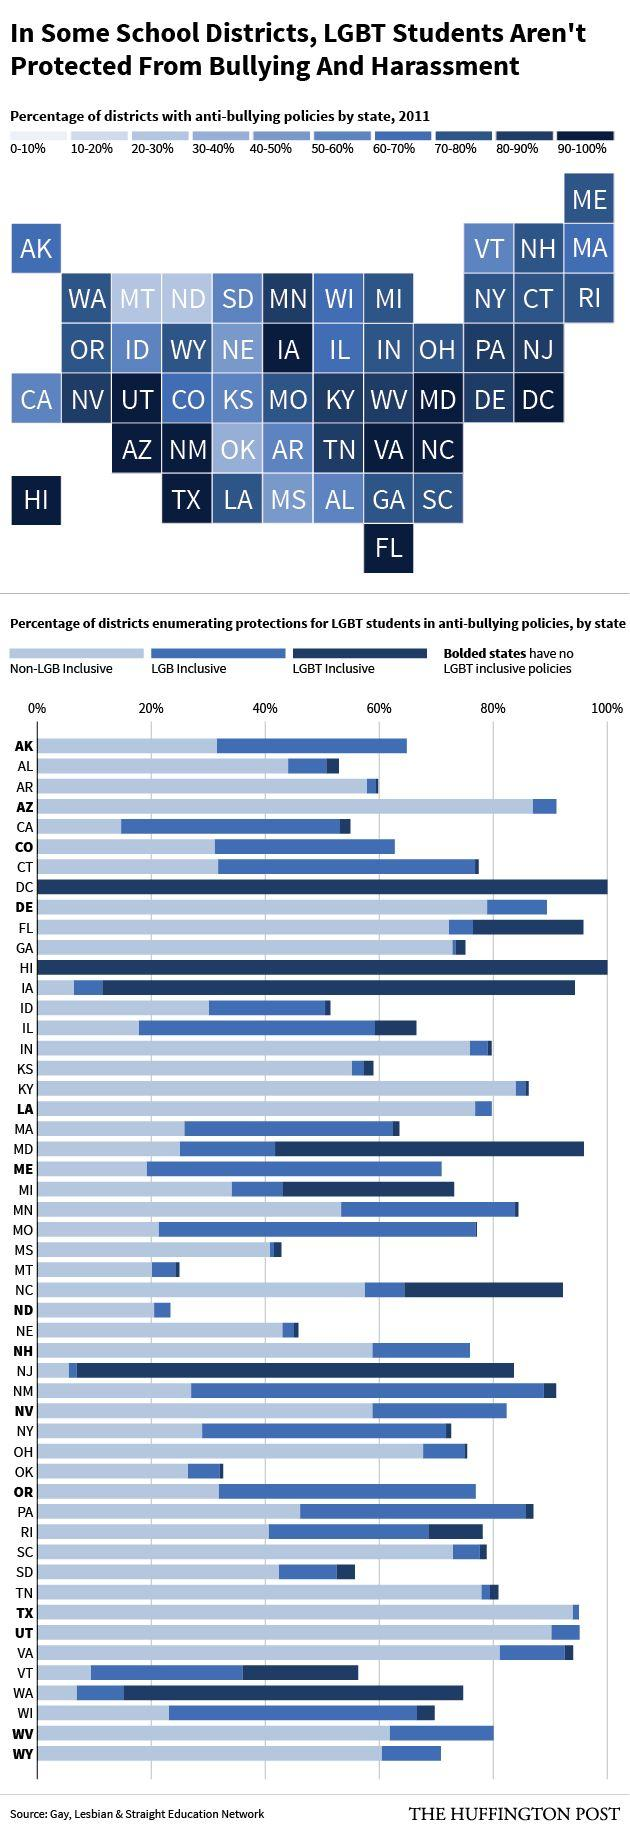Draw attention to some important aspects in this diagram. Eleven school districts have implemented anti-bullying policies that are 90-100% effective by state. Washington D.C. and Hawaii are the two school districts that fully include and support the LGBT community. As of my knowledge cutoff date, approximately 14 school districts did not have LGBT inclusive policies in place. 